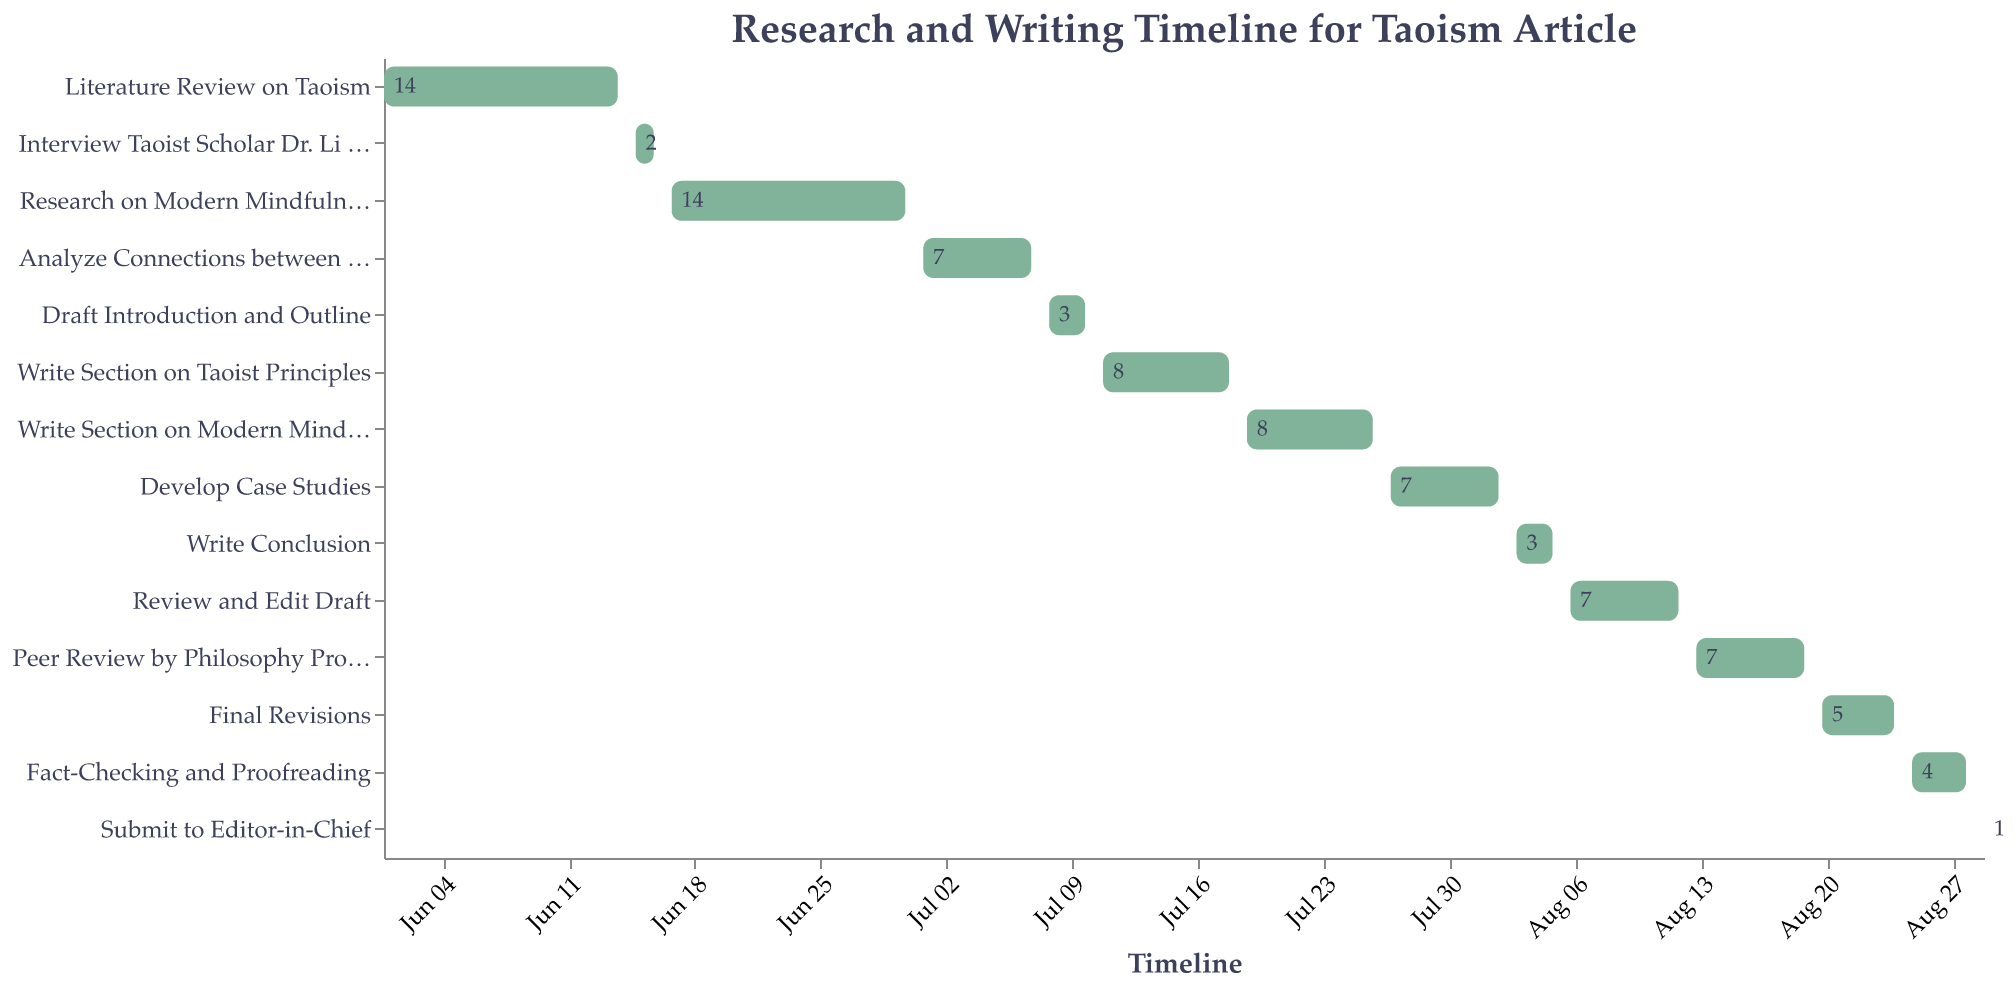What is the duration of the "Interview Taoist Scholar Dr. Li Wei" task? The "Interview Taoist Scholar Dr. Li Wei" task has its duration labeled directly on the bar in the figure. It spans 2 days.
Answer: 2 days When does the "Write Conclusion" task start and end? The "Write Conclusion" task starts on August 3rd and ends on August 5th, as seen on the timeline of the Gantt Chart.
Answer: August 3 - August 5 How many tasks are scheduled to happen in July? By checking the timeline on the Gantt Chart, there are five tasks scheduled in July: "Analyze Connections between Taoism and Mindfulness", "Draft Introduction and Outline", "Write Section on Taoist Principles", "Write Section on Modern Mindfulness", and "Develop Case Studies".
Answer: 5 tasks Which task has the shortest duration and what is it? By comparing the durations labeled on the bars, the "Submit to Editor-in-Chief" task has the shortest duration, which is 1 day.
Answer: "Submit to Editor-in-Chief" What is the total duration from the start of "Literature Review on Taoism" to the end of "Submit to Editor-in-Chief"? The "Literature Review on Taoism" starts on June 1st and the "Submit to Editor-in-Chief" ends on August 29th. The total duration is the difference between these two dates.
Answer: 90 days Which is longer, "Research on Modern Mindfulness Practices" or "Write Section on Taoist Principles"? By comparing the duration labels on the bars, "Research on Modern Mindfulness Practices" (14 days) is longer than "Write Section on Taoist Principles" (8 days).
Answer: "Research on Modern Mindfulness Practices" How many drafts and reviews phases are there in the schedule? Looking at the tasks, drafts and reviews include "Draft Introduction and Outline", "Review and Edit Draft", "Peer Review by Philosophy Professor", and "Final Revisions" which are four phases.
Answer: 4 phases When do the tasks related to writing sections end? By referring to the Gantt Chart, the "Write Section on Modern Mindfulness" is the last writing task and it ends on July 26th.
Answer: July 26 How many tasks overlap with the "Develop Case Studies" task? The "Develop Case Studies" task (July 27 - August 2) overlaps with the "Write Section on Modern Mindfulness" (until July 26), "Write Conclusion" (August 3 onward), "Review and Edit Draft" (August 6 onward), with no overlapping tasks within this timeframe.
Answer: 0 tasks What task follows directly after the "Peer Review by Philosophy Professor"? According to the Gantt Chart, the "Final Revisions" task follows directly after "Peer Review by Philosophy Professor".
Answer: "Final Revisions" 